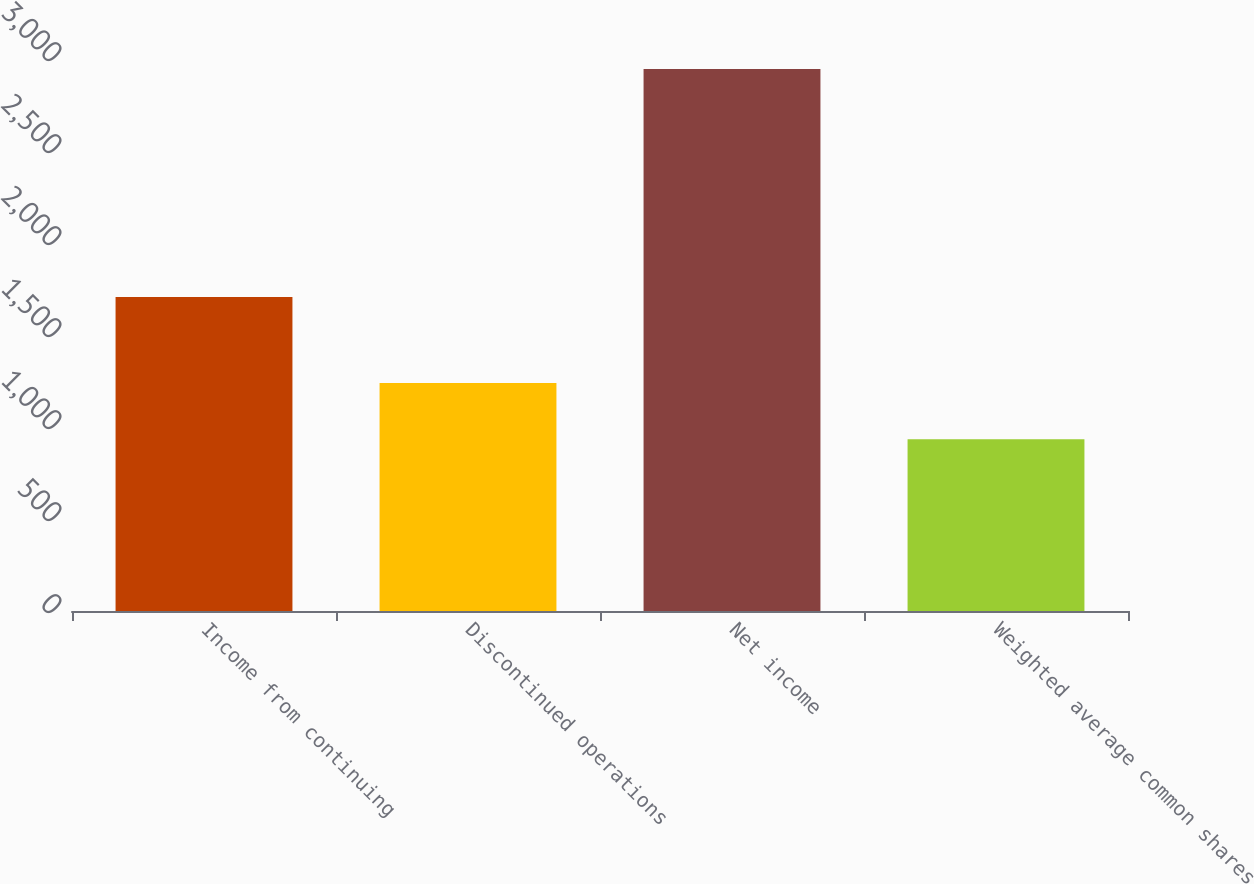Convert chart. <chart><loc_0><loc_0><loc_500><loc_500><bar_chart><fcel>Income from continuing<fcel>Discontinued operations<fcel>Net income<fcel>Weighted average common shares<nl><fcel>1707<fcel>1239<fcel>2946<fcel>933.6<nl></chart> 